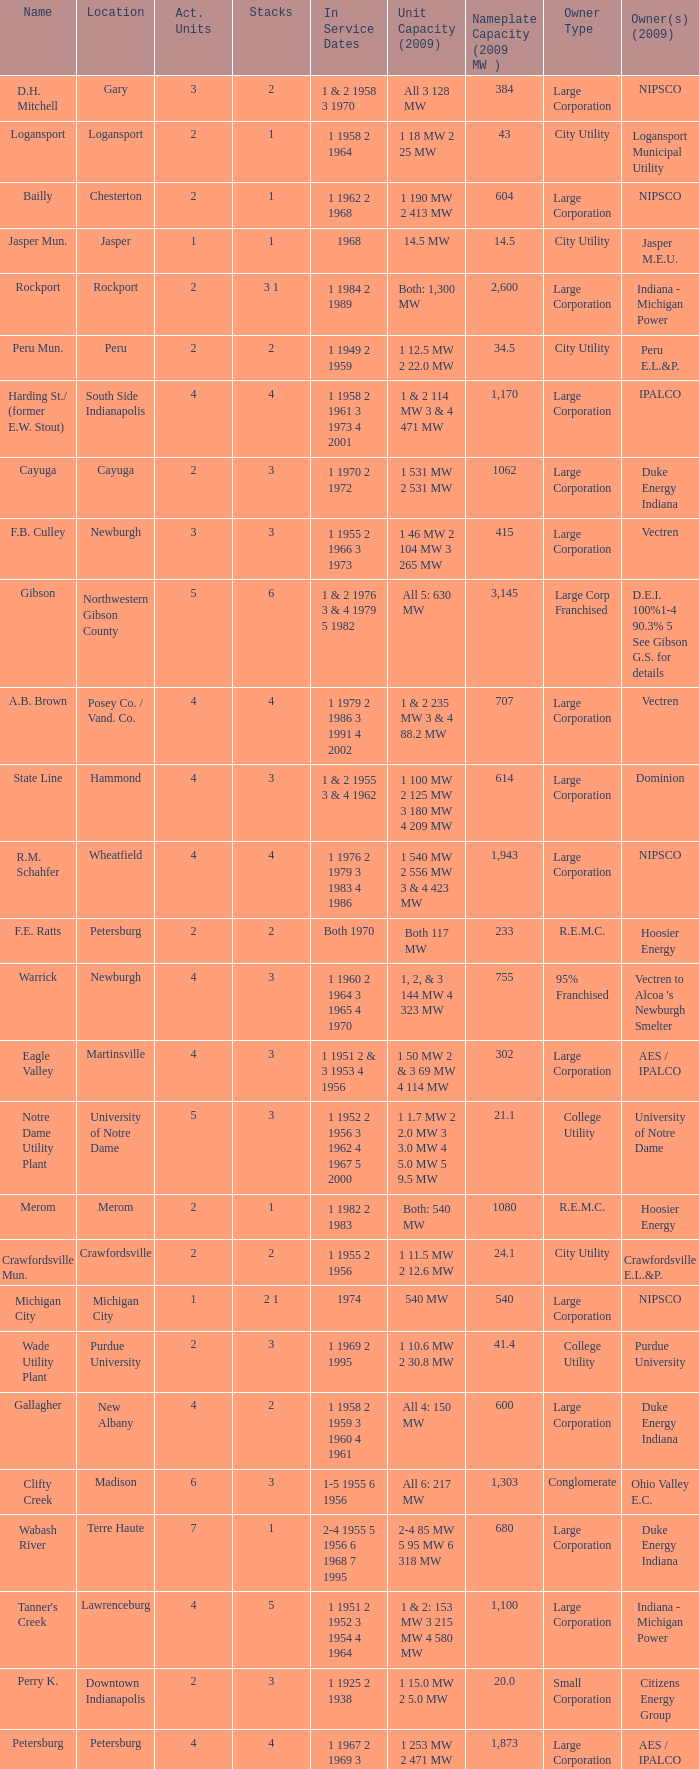Name the number for service dates for hoosier energy for petersburg 1.0. 